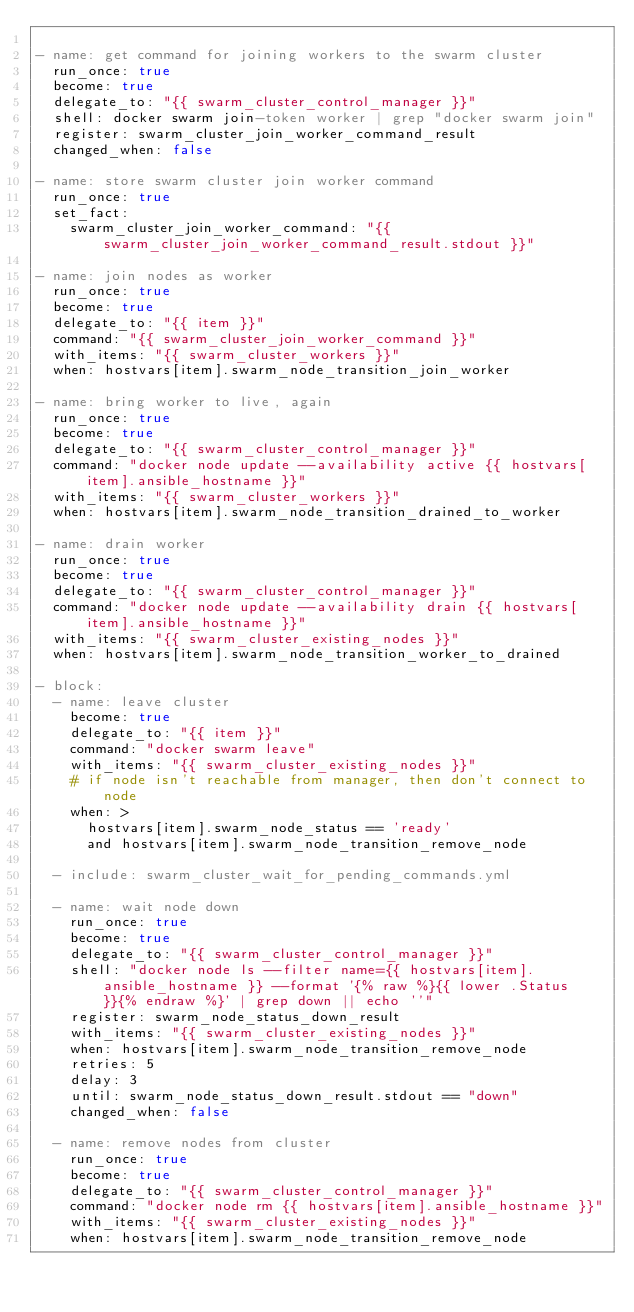Convert code to text. <code><loc_0><loc_0><loc_500><loc_500><_YAML_>
- name: get command for joining workers to the swarm cluster
  run_once: true
  become: true
  delegate_to: "{{ swarm_cluster_control_manager }}"
  shell: docker swarm join-token worker | grep "docker swarm join"
  register: swarm_cluster_join_worker_command_result
  changed_when: false

- name: store swarm cluster join worker command
  run_once: true
  set_fact:
    swarm_cluster_join_worker_command: "{{ swarm_cluster_join_worker_command_result.stdout }}"

- name: join nodes as worker
  run_once: true
  become: true
  delegate_to: "{{ item }}"
  command: "{{ swarm_cluster_join_worker_command }}"
  with_items: "{{ swarm_cluster_workers }}"
  when: hostvars[item].swarm_node_transition_join_worker

- name: bring worker to live, again
  run_once: true
  become: true
  delegate_to: "{{ swarm_cluster_control_manager }}"
  command: "docker node update --availability active {{ hostvars[item].ansible_hostname }}"
  with_items: "{{ swarm_cluster_workers }}"
  when: hostvars[item].swarm_node_transition_drained_to_worker

- name: drain worker
  run_once: true
  become: true
  delegate_to: "{{ swarm_cluster_control_manager }}"
  command: "docker node update --availability drain {{ hostvars[item].ansible_hostname }}"
  with_items: "{{ swarm_cluster_existing_nodes }}"
  when: hostvars[item].swarm_node_transition_worker_to_drained
  
- block:
  - name: leave cluster
    become: true
    delegate_to: "{{ item }}"
    command: "docker swarm leave"
    with_items: "{{ swarm_cluster_existing_nodes }}"
    # if node isn't reachable from manager, then don't connect to node
    when: >
      hostvars[item].swarm_node_status == 'ready'
      and hostvars[item].swarm_node_transition_remove_node
  
  - include: swarm_cluster_wait_for_pending_commands.yml

  - name: wait node down
    run_once: true
    become: true
    delegate_to: "{{ swarm_cluster_control_manager }}"
    shell: "docker node ls --filter name={{ hostvars[item].ansible_hostname }} --format '{% raw %}{{ lower .Status }}{% endraw %}' | grep down || echo ''"
    register: swarm_node_status_down_result
    with_items: "{{ swarm_cluster_existing_nodes }}"
    when: hostvars[item].swarm_node_transition_remove_node
    retries: 5
    delay: 3
    until: swarm_node_status_down_result.stdout == "down"
    changed_when: false

  - name: remove nodes from cluster
    run_once: true
    become: true
    delegate_to: "{{ swarm_cluster_control_manager }}"
    command: "docker node rm {{ hostvars[item].ansible_hostname }}"
    with_items: "{{ swarm_cluster_existing_nodes }}"
    when: hostvars[item].swarm_node_transition_remove_node

</code> 